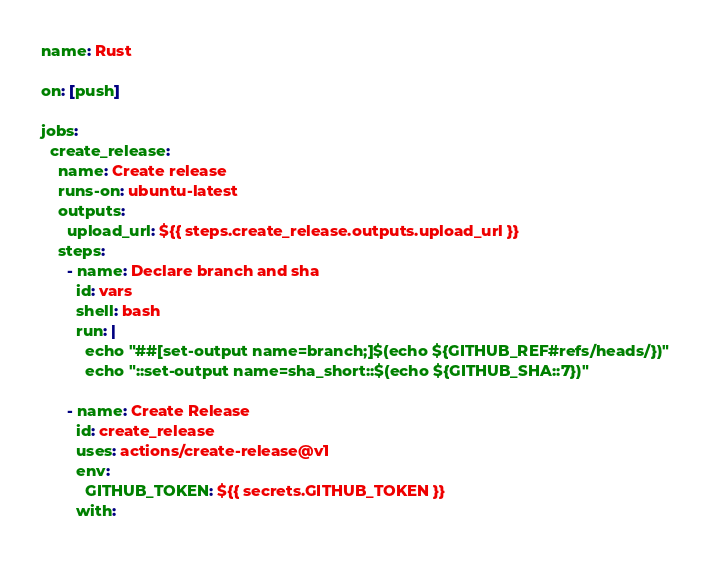<code> <loc_0><loc_0><loc_500><loc_500><_YAML_>name: Rust

on: [push]

jobs:
  create_release:
    name: Create release
    runs-on: ubuntu-latest
    outputs:
      upload_url: ${{ steps.create_release.outputs.upload_url }}
    steps:
      - name: Declare branch and sha
        id: vars
        shell: bash
        run: |
          echo "##[set-output name=branch;]$(echo ${GITHUB_REF#refs/heads/})"
          echo "::set-output name=sha_short::$(echo ${GITHUB_SHA::7})"

      - name: Create Release
        id: create_release
        uses: actions/create-release@v1
        env:
          GITHUB_TOKEN: ${{ secrets.GITHUB_TOKEN }}
        with:</code> 